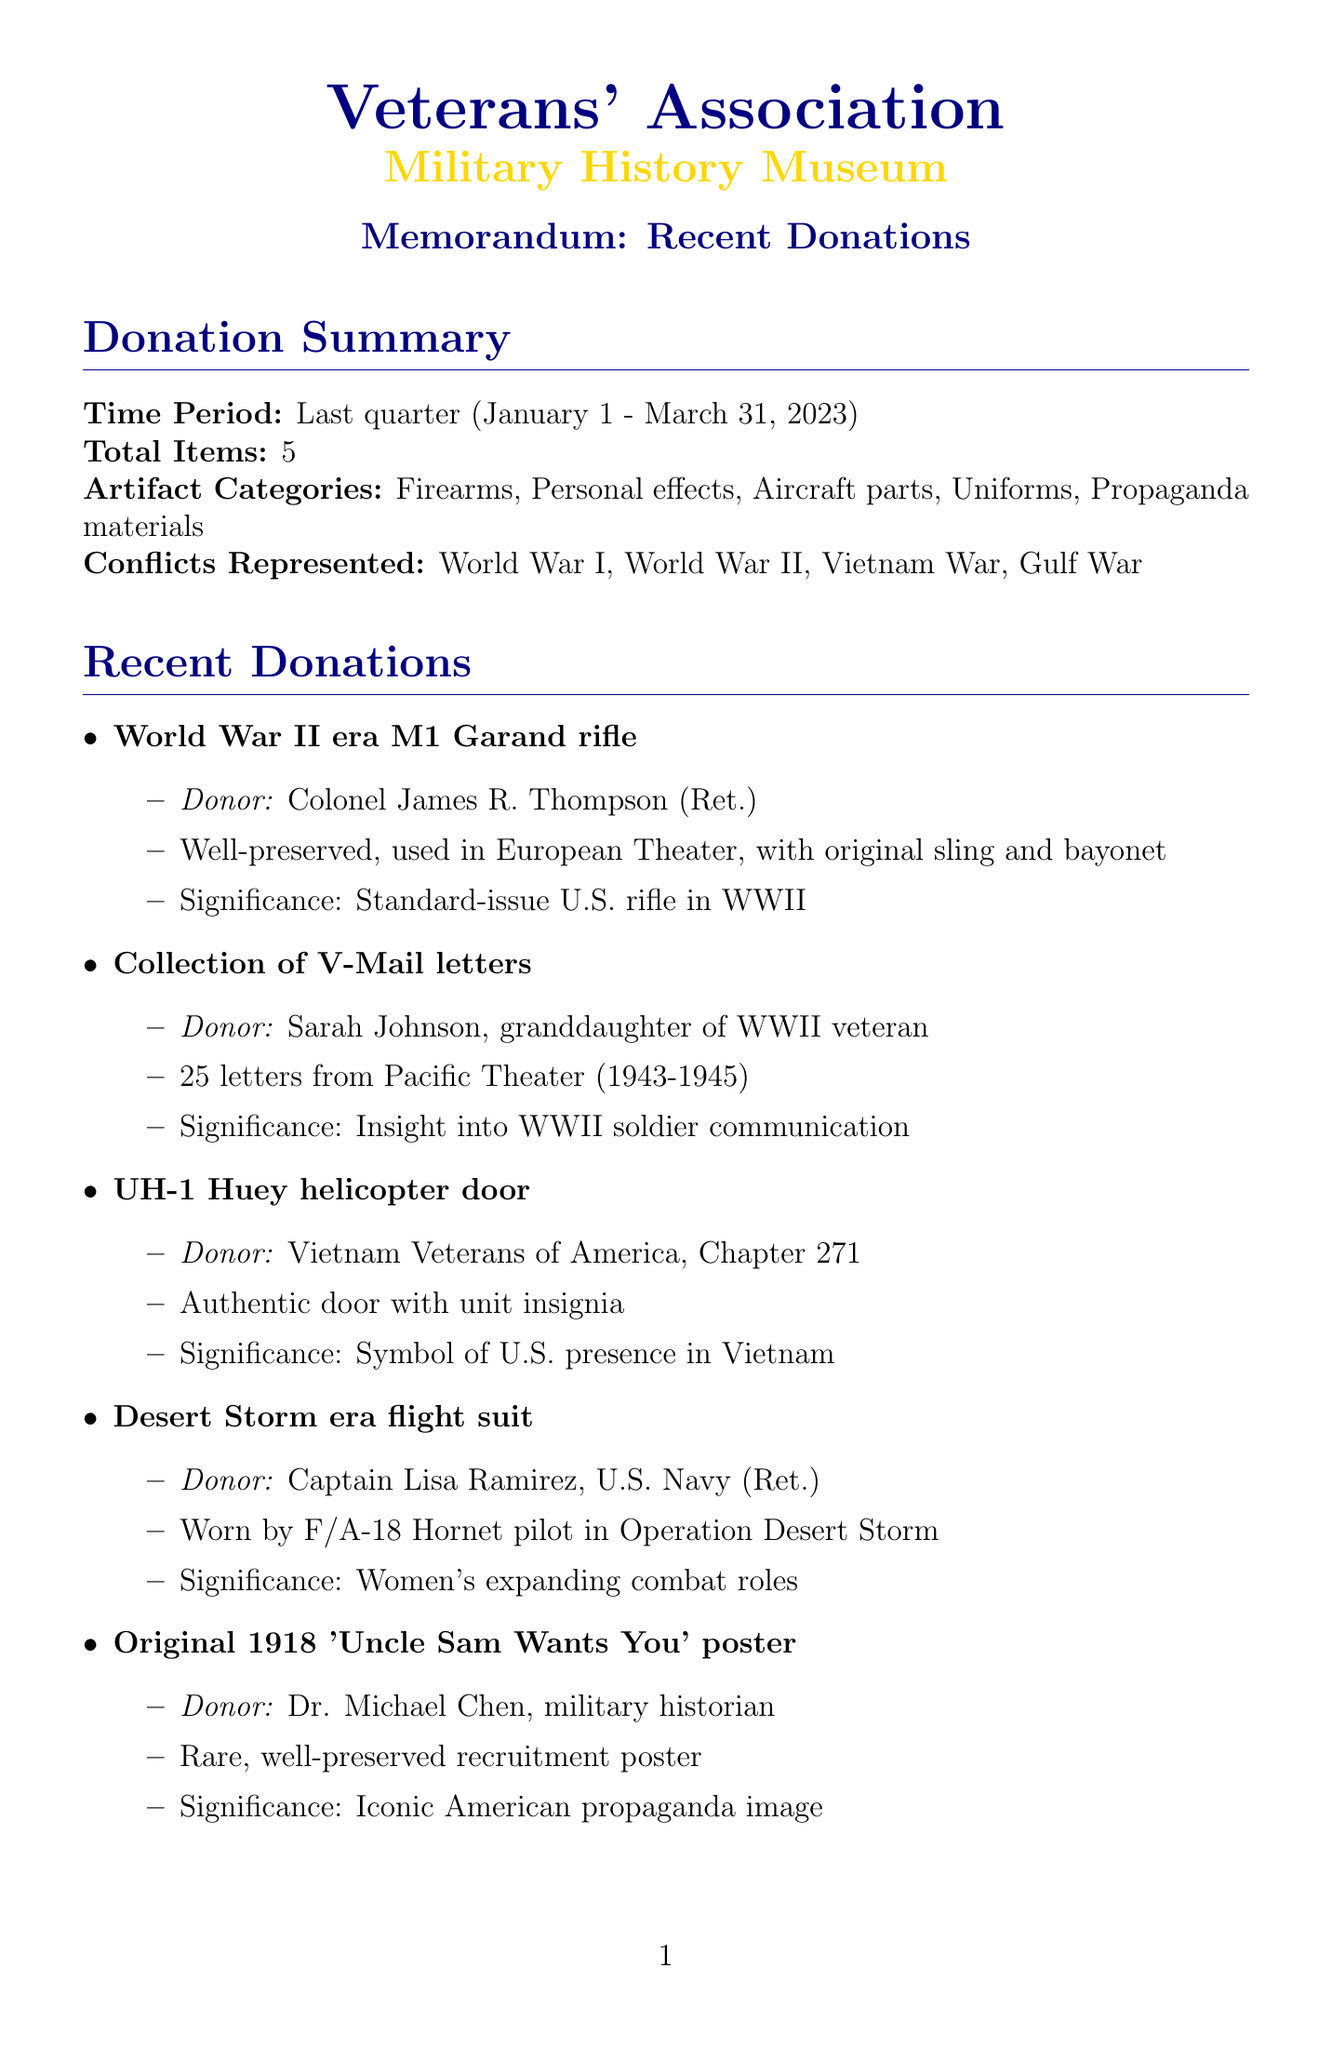What is the total number of items donated? The total number of items donated is stated in the summary section, which lists the total items as 5.
Answer: 5 Who donated the World War II era M1 Garand rifle? The donor of the M1 Garand rifle is mentioned directly in the recent donations list.
Answer: Colonel James R. Thompson (Ret.) What artifact is associated with Sarah Johnson? The artifact corresponding to Sarah Johnson is specified in the recent donations section.
Answer: Collection of V-Mail letters What date is the Donor Acknowledgment Event scheduled for? The date of the acknowledgment event is detailed in the event section of the document.
Answer: April 15, 2023 How many new exhibits are planned for the museum? The number of new exhibits planned is noted in the museum impact section, indicating that there are 2 new exhibits planned.
Answer: 2 What significant historical event does the UH-1 Huey helicopter door represent? The historical significance of the helicopter door is described, focusing on its role in Vietnam.
Answer: U.S. military presence in Vietnam What is the primary conflict represented by the donated flight suit? The conflict connected to the flight suit is explicitly defined in the donation summary.
Answer: Gulf War Who is the special guest at the acknowledgment event? The special guest for the event is identified in the details of the acknowledgment event.
Answer: Major General Robert F. Williams, U.S. Army (Ret.) 